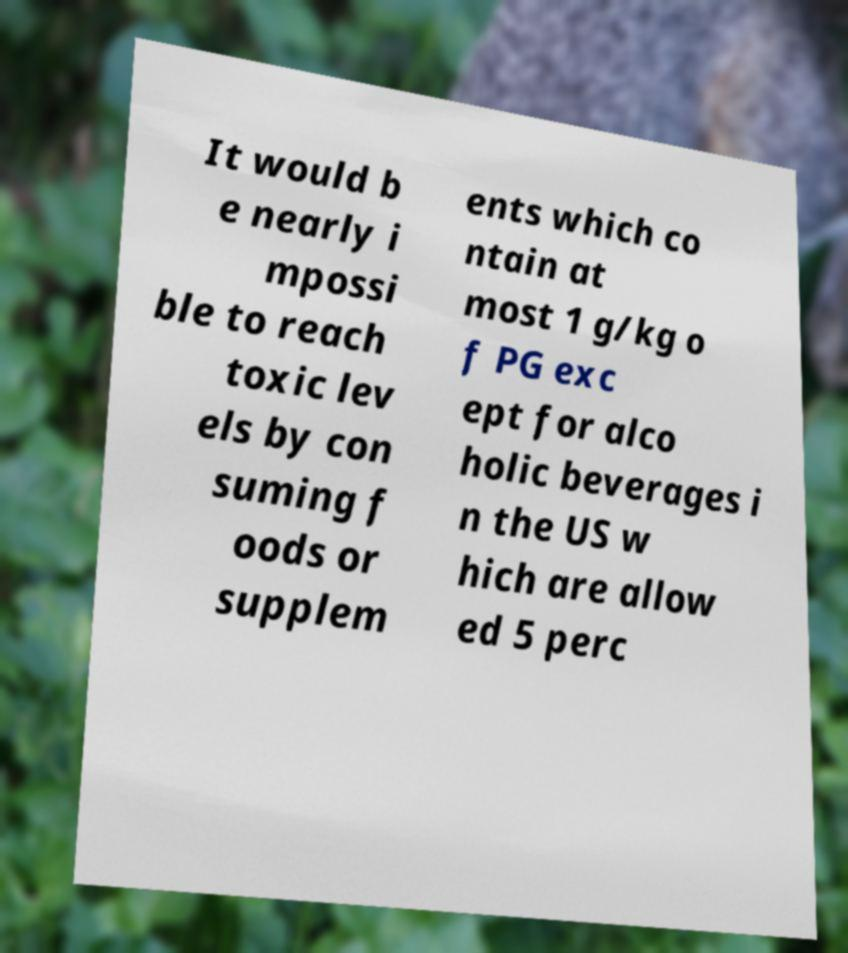There's text embedded in this image that I need extracted. Can you transcribe it verbatim? It would b e nearly i mpossi ble to reach toxic lev els by con suming f oods or supplem ents which co ntain at most 1 g/kg o f PG exc ept for alco holic beverages i n the US w hich are allow ed 5 perc 